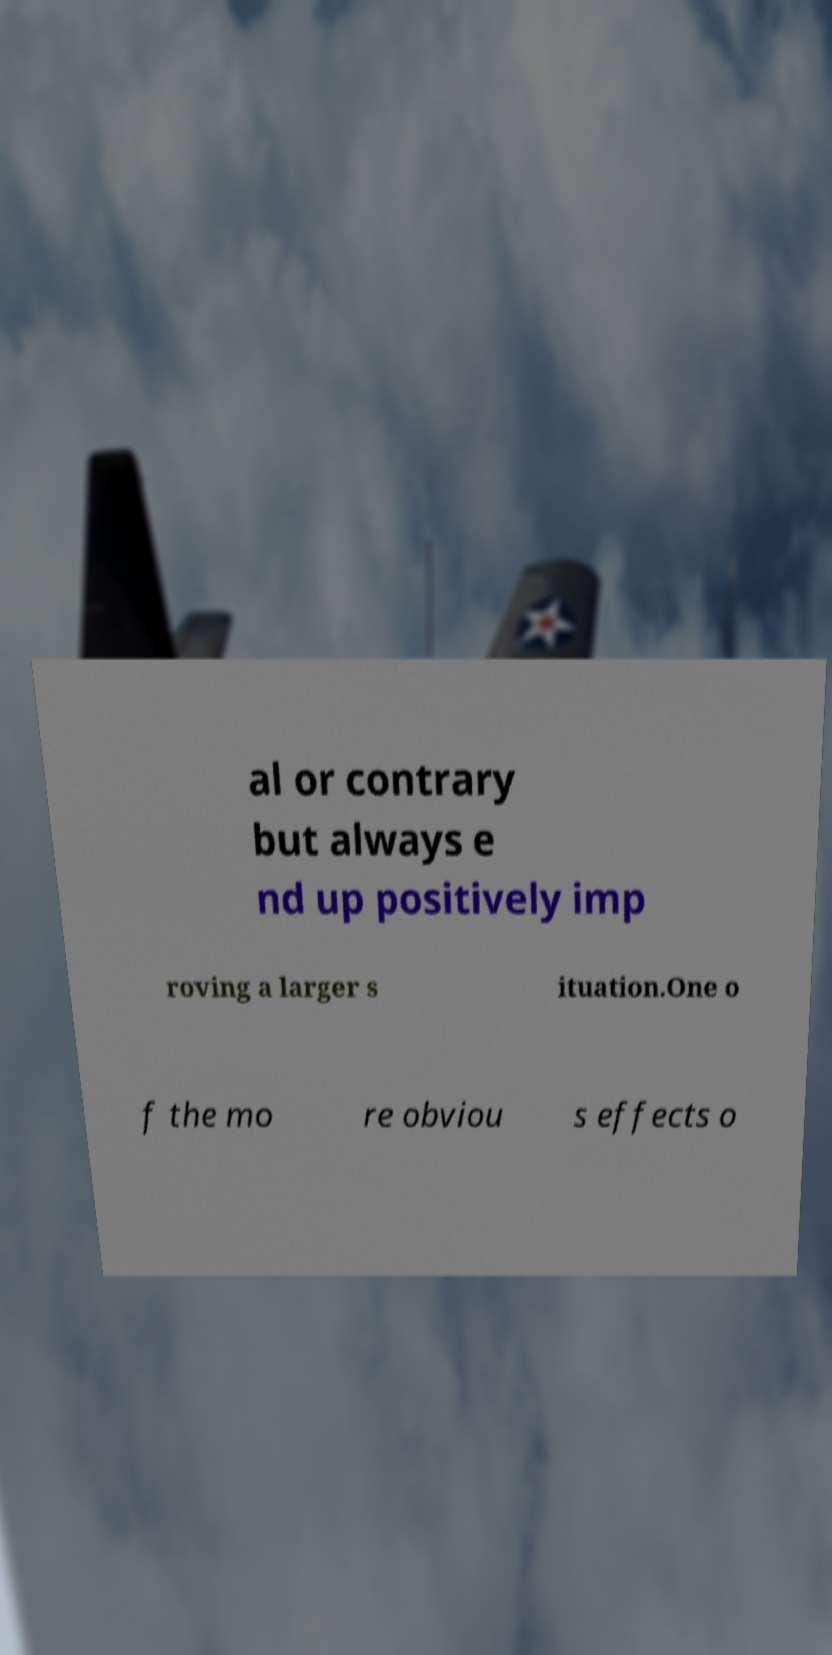There's text embedded in this image that I need extracted. Can you transcribe it verbatim? al or contrary but always e nd up positively imp roving a larger s ituation.One o f the mo re obviou s effects o 